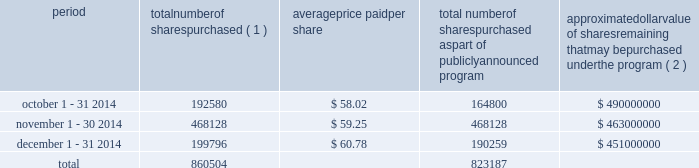Celanese purchases of its equity securities information regarding repurchases of our common stock during the three months ended december 31 , 2014 is as follows : period number of shares purchased ( 1 ) average price paid per share total number of shares purchased as part of publicly announced program approximate dollar value of shares remaining that may be purchased under the program ( 2 ) .
___________________________ ( 1 ) includes 27780 and 9537 for october and december 2014 , respectively , related to shares withheld from employees to cover their statutory minimum withholding requirements for personal income taxes related to the vesting of restricted stock units .
( 2 ) our board of directors has authorized the aggregate repurchase of $ 1.4 billion of our common stock since february 2008 .
See note 17 - stockholders' equity in the accompanying consolidated financial statements for further information .
Performance graph the following performance graph and related information shall not be deemed "soliciting material" or to be "filed" with the securities and exchange commission , nor shall such information be incorporated by reference into any future filing under the securities act of 1933 or securities exchange act of 1934 , each as amended , except to the extent that we specifically incorporate it by reference into such filing .
Comparison of cumulative total return .
In 2014 what was the percent of shares withheld from employees to cover their statutory minimum withholding requirements for personal income taxes to the shares purchased? 
Rationale: the percent of the shares withheld from employees to cover their statutory minimum withholding requirements to those purchased is 4.3%
Computations: ((27780 + 9537) / 860504)
Answer: 0.04337. Celanese purchases of its equity securities information regarding repurchases of our common stock during the three months ended december 31 , 2014 is as follows : period number of shares purchased ( 1 ) average price paid per share total number of shares purchased as part of publicly announced program approximate dollar value of shares remaining that may be purchased under the program ( 2 ) .
___________________________ ( 1 ) includes 27780 and 9537 for october and december 2014 , respectively , related to shares withheld from employees to cover their statutory minimum withholding requirements for personal income taxes related to the vesting of restricted stock units .
( 2 ) our board of directors has authorized the aggregate repurchase of $ 1.4 billion of our common stock since february 2008 .
See note 17 - stockholders' equity in the accompanying consolidated financial statements for further information .
Performance graph the following performance graph and related information shall not be deemed "soliciting material" or to be "filed" with the securities and exchange commission , nor shall such information be incorporated by reference into any future filing under the securities act of 1933 or securities exchange act of 1934 , each as amended , except to the extent that we specifically incorporate it by reference into such filing .
Comparison of cumulative total return .
What is the total value paid for purchased shares during november 2014? 
Computations: ((468128 * 59.25) / 1000000)
Answer: 27.73658. 